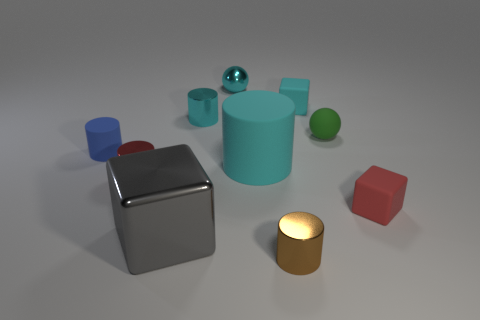Subtract all brown balls. How many cyan cylinders are left? 2 Subtract all tiny cubes. How many cubes are left? 1 Subtract all brown cylinders. How many cylinders are left? 4 Subtract 1 cylinders. How many cylinders are left? 4 Subtract all gray cylinders. Subtract all blue blocks. How many cylinders are left? 5 Subtract all tiny red cylinders. Subtract all small brown metallic cylinders. How many objects are left? 8 Add 3 cyan rubber objects. How many cyan rubber objects are left? 5 Add 3 tiny red rubber objects. How many tiny red rubber objects exist? 4 Subtract 0 blue cubes. How many objects are left? 10 Subtract all balls. How many objects are left? 8 